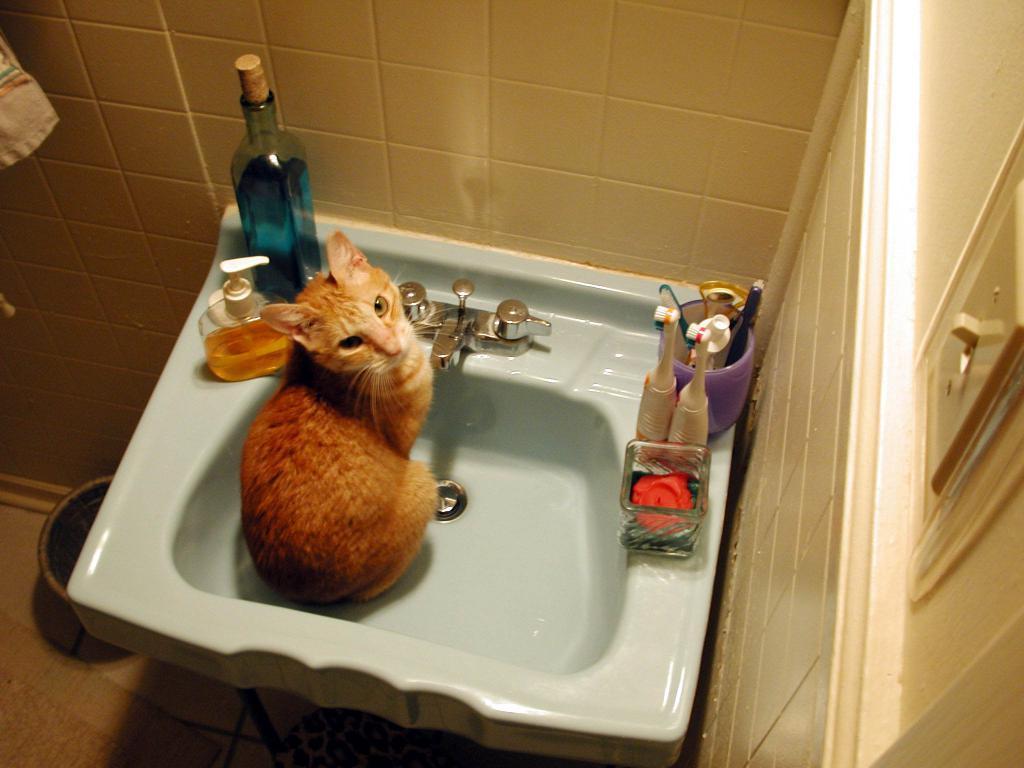In one or two sentences, can you explain what this image depicts? In this image there is a sink, on that sink there are brushes, bottles and there is a cat around the sink there is a wall, below that there is a bucket. 